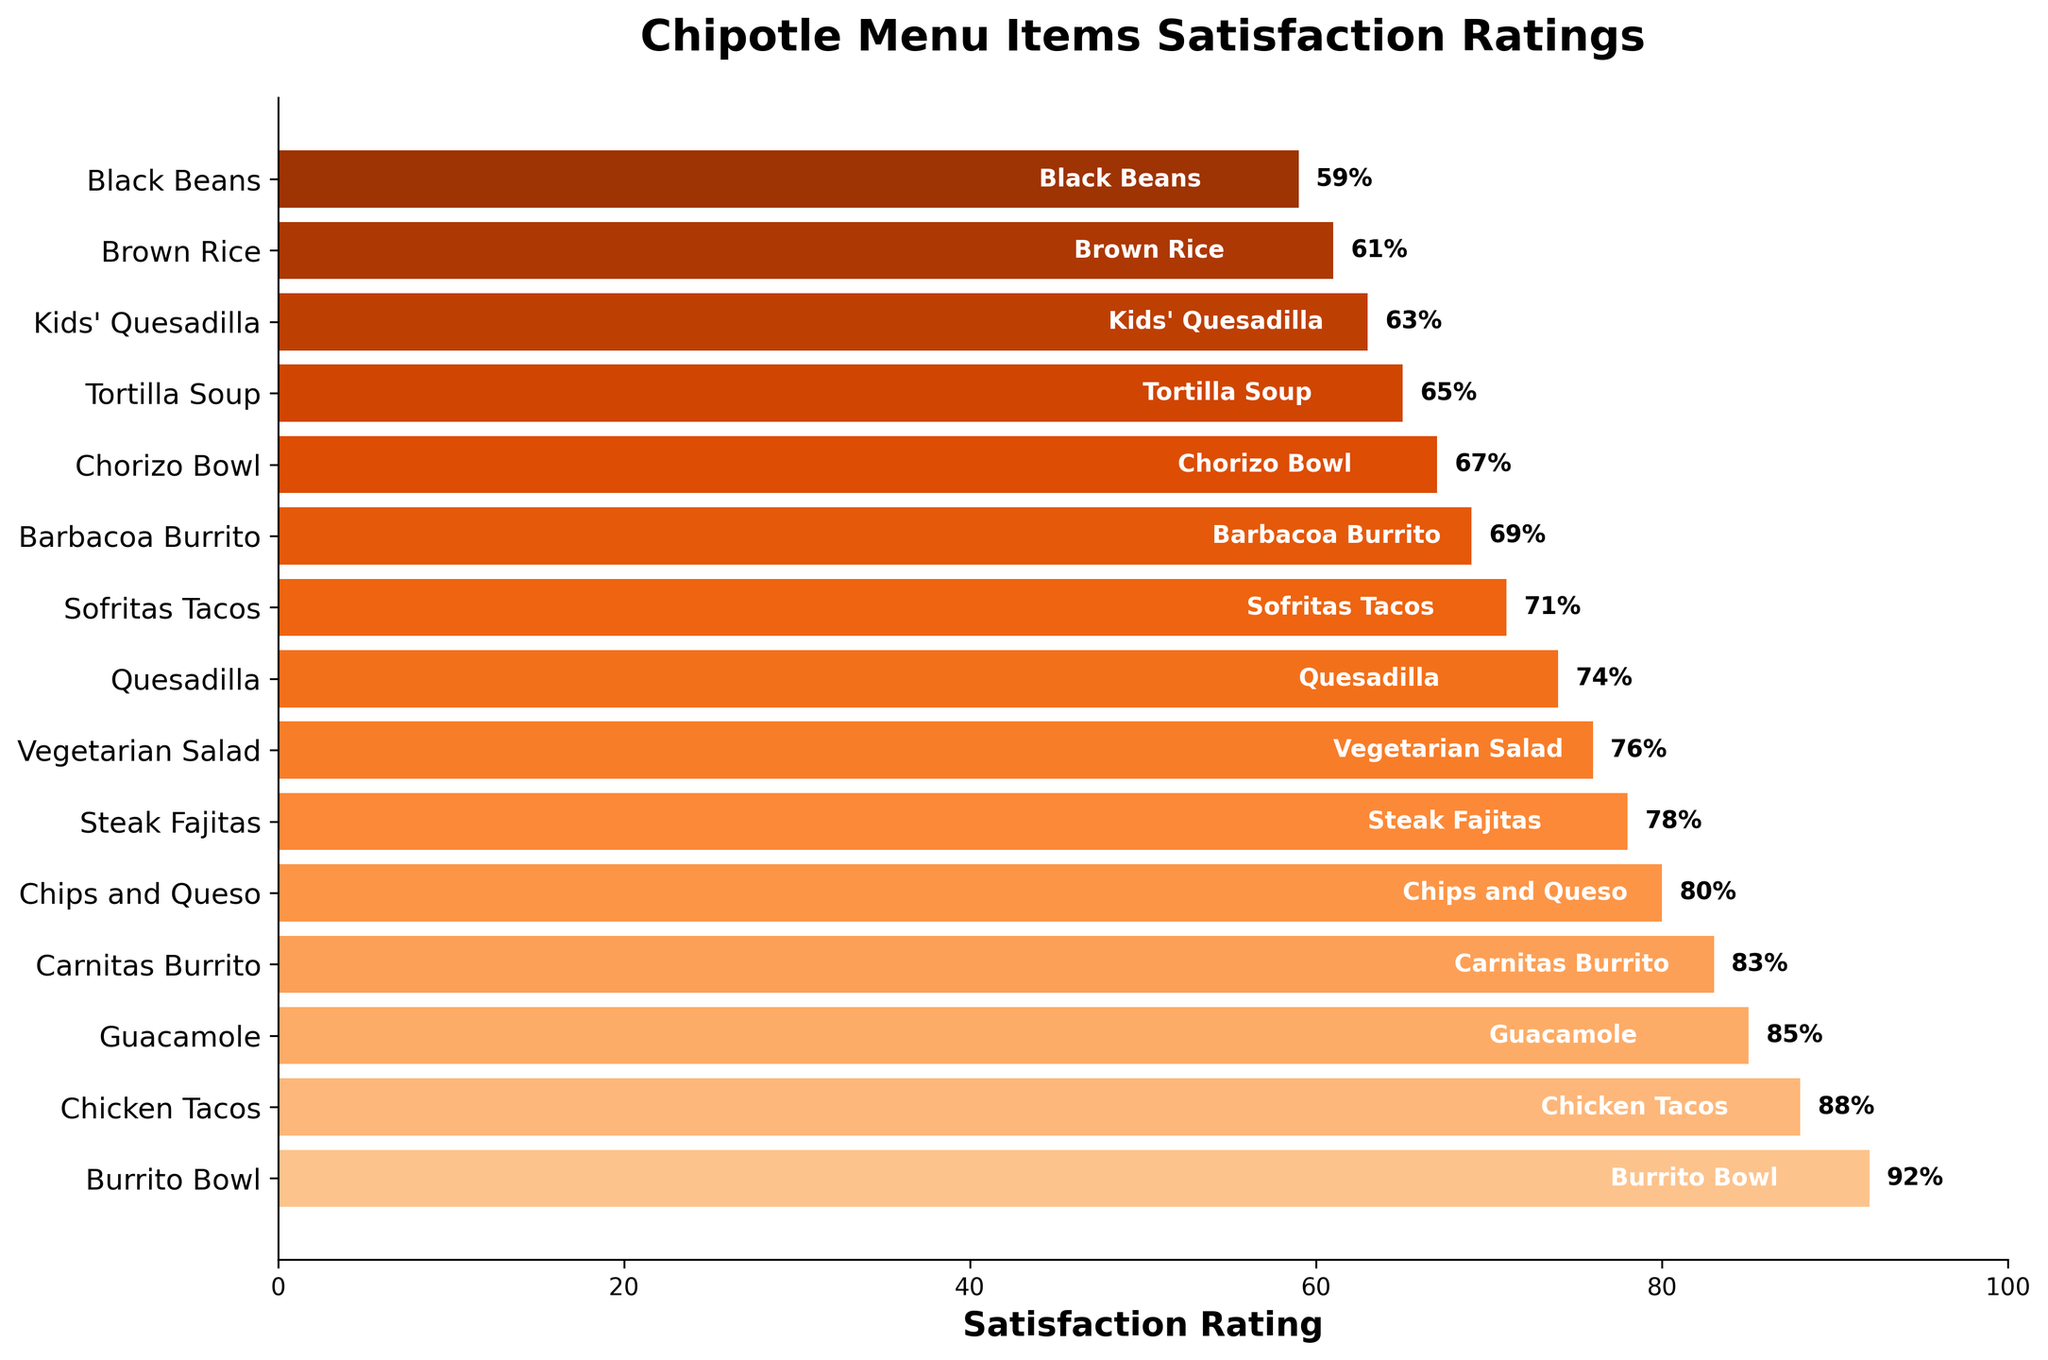What's the difference in satisfaction ratings between Burrito Bowl and Barbacoa Burrito? Burrito Bowl has a satisfaction rating of 92, while Barbacoa Burrito has a rating of 69. The difference is 92 - 69 = 23.
Answer: 23 Which menu item has the highest satisfaction rating? Referring to the figure, Burrito Bowl has the highest satisfaction rating of 92.
Answer: Burrito Bowl Are Chicken Tacos rated higher than Carnitas Burrito? The satisfaction rating for Chicken Tacos is 88, whereas Carnitas Burrito has a rating of 83. Since 88 is greater than 83, Chicken Tacos are rated higher.
Answer: Yes What is the range of satisfaction ratings for the menu items? The range is calculated as the difference between the highest and lowest values. The highest rating is 92 (Burrito Bowl) and the lowest is 59 (Black Beans). So, the range is 92 - 59 = 33.
Answer: 33 Which three menu items have the closest satisfaction ratings? Looking at the figure, Guacamole (85), Carnitas Burrito (83), and Chips and Queso (80) have ratings that are close to each other within a range of 5.
Answer: Guacamole, Carnitas Burrito, Chips and Queso Which menu item is rated lowest? According to the figure, Black Beans has the lowest satisfaction rating of 59.
Answer: Black Beans How many menu items have a satisfaction rating above 80? From the figure, the menu items with ratings above 80 are Burrito Bowl (92), Chicken Tacos (88), Guacamole (85), and Carnitas Burrito (83). There are 4 such items.
Answer: 4 What's the combined satisfaction rating for Sofritas Tacos and Chorizo Bowl? The satisfaction rating for Sofritas Tacos is 71 and for Chorizo Bowl is 67. Their combined rating is 71 + 67 = 138.
Answer: 138 